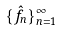Convert formula to latex. <formula><loc_0><loc_0><loc_500><loc_500>\{ \hat { f } _ { n } \} _ { n = 1 } ^ { \infty }</formula> 